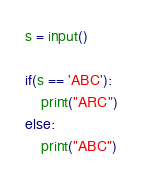<code> <loc_0><loc_0><loc_500><loc_500><_Python_>s = input()

if(s == 'ABC'):
    print("ARC")
else:
    print("ABC")</code> 